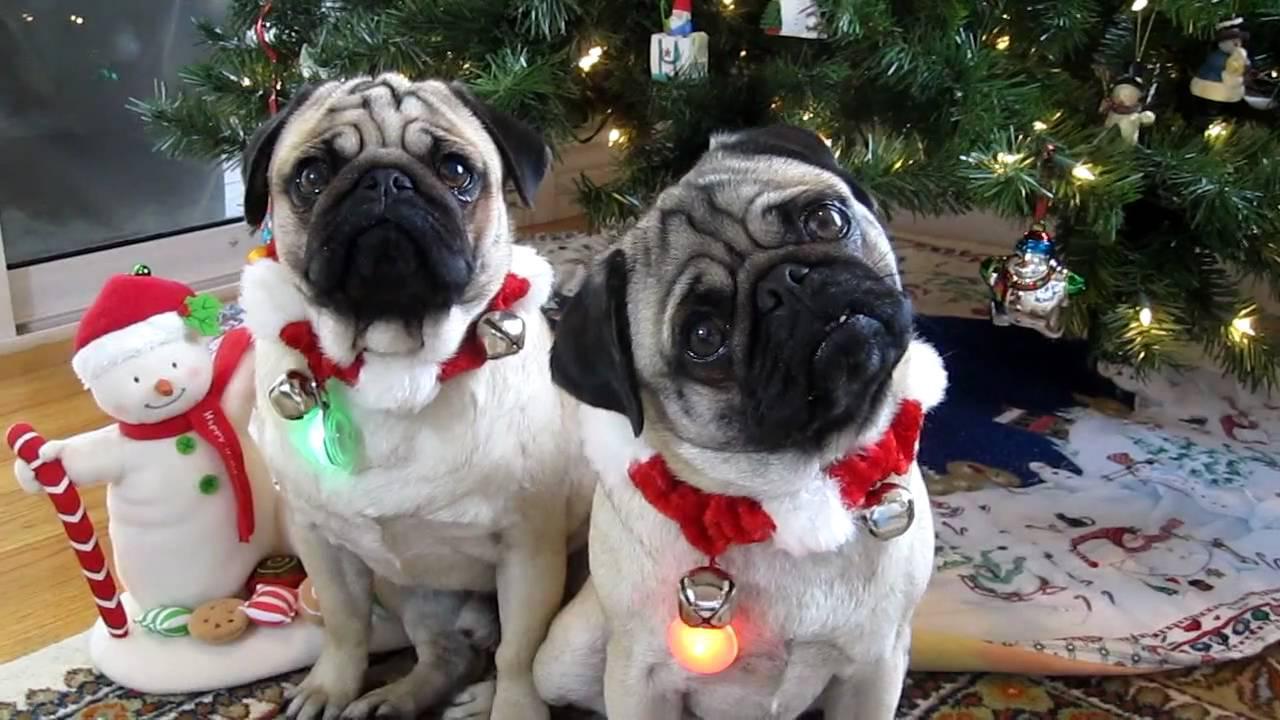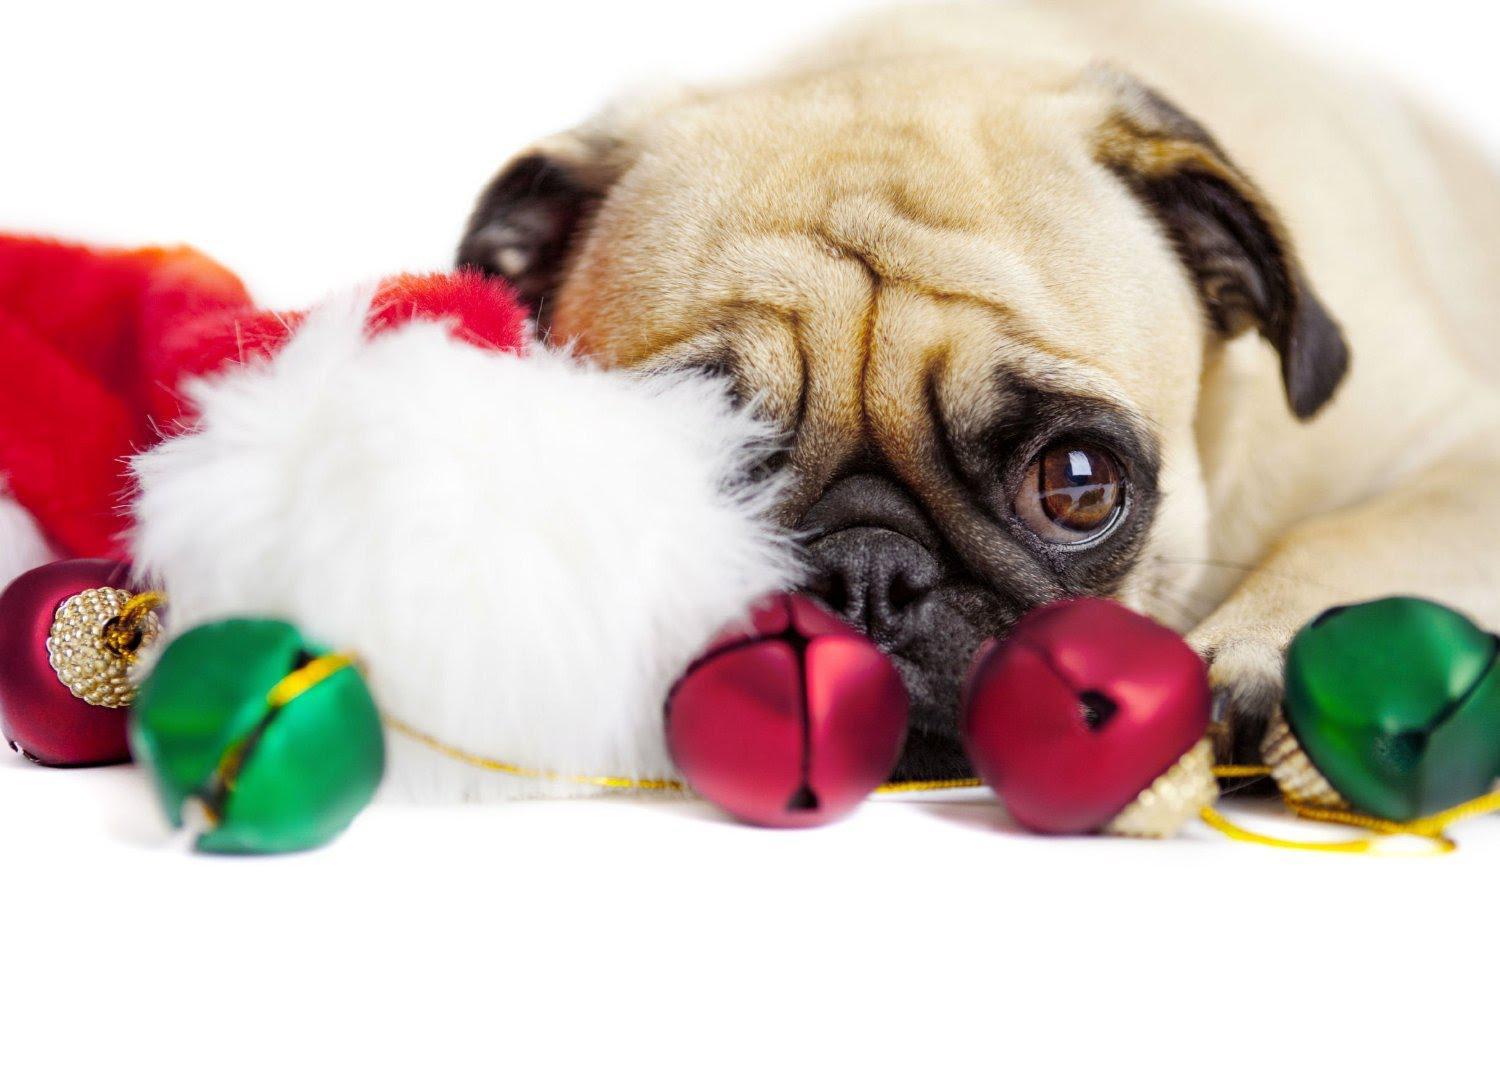The first image is the image on the left, the second image is the image on the right. Given the left and right images, does the statement "One dog is wearing a santa clause hat." hold true? Answer yes or no. No. 